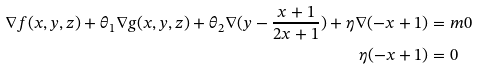<formula> <loc_0><loc_0><loc_500><loc_500>\nabla f ( x , y , z ) + \theta _ { 1 } \nabla g ( x , y , z ) + \theta _ { 2 } \nabla ( y - \frac { x + 1 } { 2 x + 1 } ) + \eta \nabla ( - x + 1 ) & = m 0 \\ \eta ( - x + 1 ) & = 0</formula> 